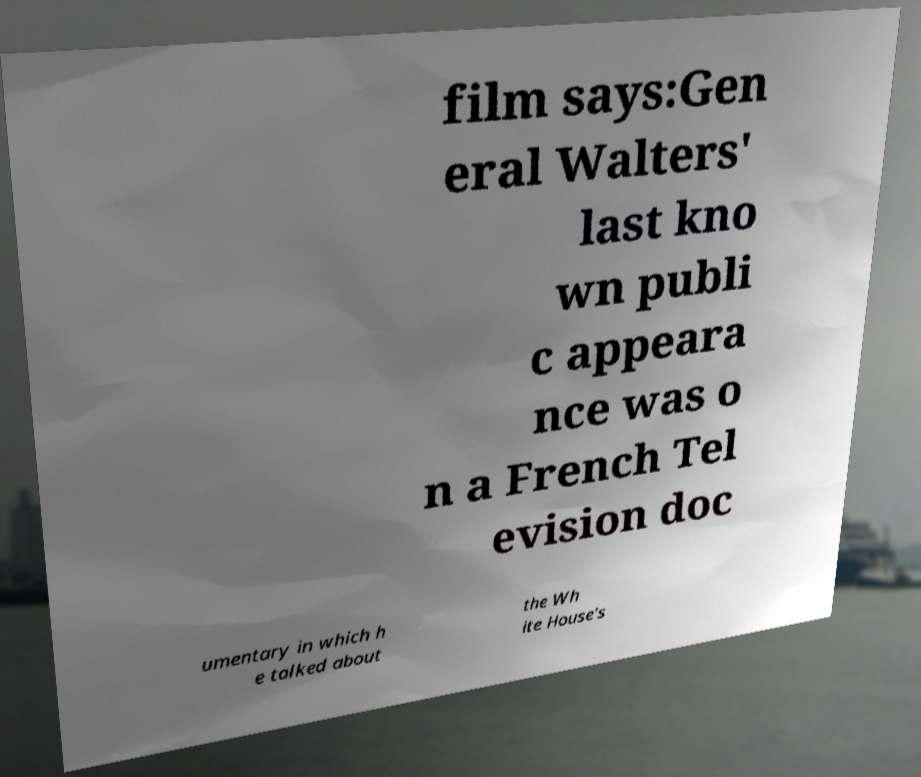Can you read and provide the text displayed in the image?This photo seems to have some interesting text. Can you extract and type it out for me? film says:Gen eral Walters' last kno wn publi c appeara nce was o n a French Tel evision doc umentary in which h e talked about the Wh ite House's 